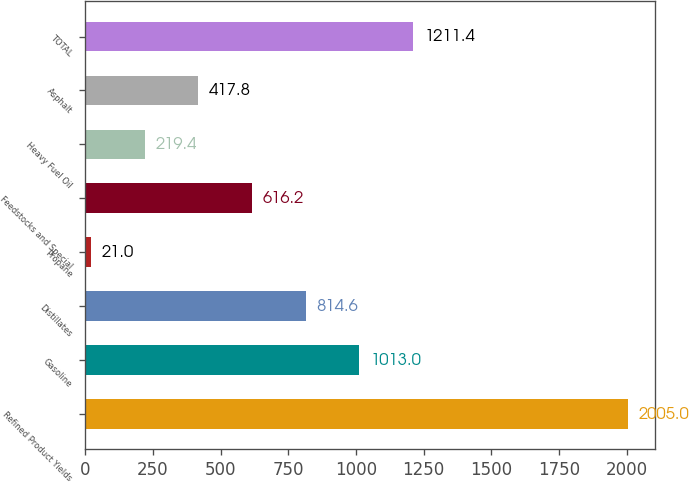<chart> <loc_0><loc_0><loc_500><loc_500><bar_chart><fcel>Refined Product Yields<fcel>Gasoline<fcel>Distillates<fcel>Propane<fcel>Feedstocks and Special<fcel>Heavy Fuel Oil<fcel>Asphalt<fcel>TOTAL<nl><fcel>2005<fcel>1013<fcel>814.6<fcel>21<fcel>616.2<fcel>219.4<fcel>417.8<fcel>1211.4<nl></chart> 